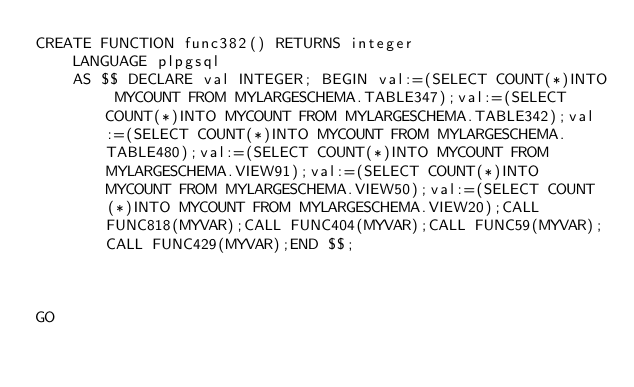<code> <loc_0><loc_0><loc_500><loc_500><_SQL_>CREATE FUNCTION func382() RETURNS integer
    LANGUAGE plpgsql
    AS $$ DECLARE val INTEGER; BEGIN val:=(SELECT COUNT(*)INTO MYCOUNT FROM MYLARGESCHEMA.TABLE347);val:=(SELECT COUNT(*)INTO MYCOUNT FROM MYLARGESCHEMA.TABLE342);val:=(SELECT COUNT(*)INTO MYCOUNT FROM MYLARGESCHEMA.TABLE480);val:=(SELECT COUNT(*)INTO MYCOUNT FROM MYLARGESCHEMA.VIEW91);val:=(SELECT COUNT(*)INTO MYCOUNT FROM MYLARGESCHEMA.VIEW50);val:=(SELECT COUNT(*)INTO MYCOUNT FROM MYLARGESCHEMA.VIEW20);CALL FUNC818(MYVAR);CALL FUNC404(MYVAR);CALL FUNC59(MYVAR);CALL FUNC429(MYVAR);END $$;



GO</code> 